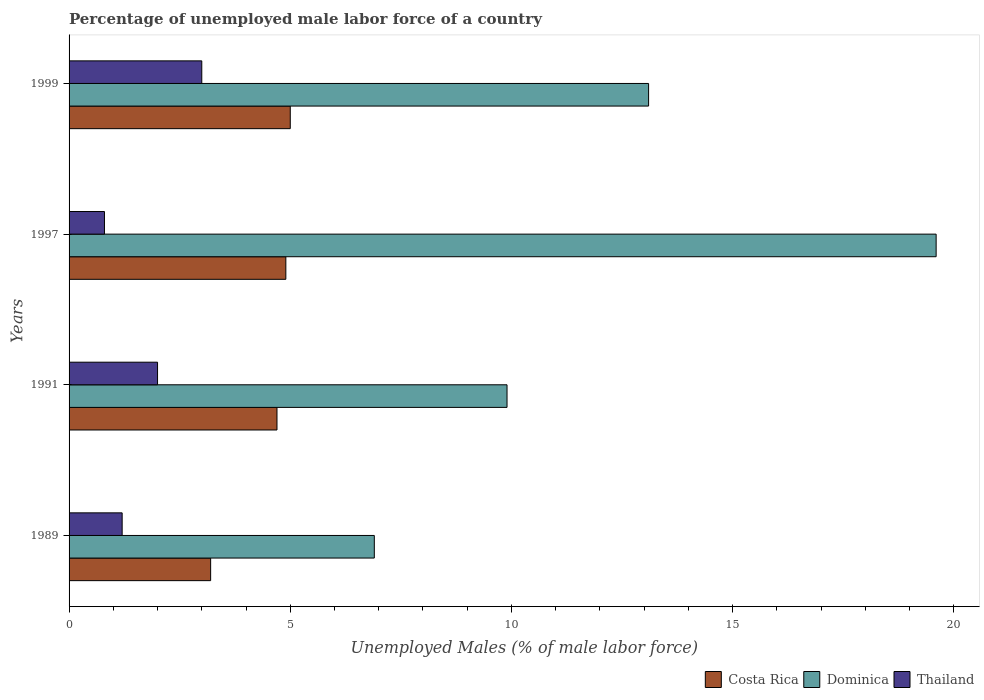How many different coloured bars are there?
Your response must be concise. 3. Are the number of bars per tick equal to the number of legend labels?
Provide a short and direct response. Yes. Are the number of bars on each tick of the Y-axis equal?
Offer a terse response. Yes. How many bars are there on the 4th tick from the top?
Offer a terse response. 3. How many bars are there on the 1st tick from the bottom?
Your response must be concise. 3. What is the label of the 4th group of bars from the top?
Make the answer very short. 1989. In how many cases, is the number of bars for a given year not equal to the number of legend labels?
Your response must be concise. 0. What is the percentage of unemployed male labor force in Costa Rica in 1999?
Offer a terse response. 5. Across all years, what is the minimum percentage of unemployed male labor force in Dominica?
Provide a succinct answer. 6.9. In which year was the percentage of unemployed male labor force in Thailand maximum?
Give a very brief answer. 1999. In which year was the percentage of unemployed male labor force in Thailand minimum?
Ensure brevity in your answer.  1997. What is the total percentage of unemployed male labor force in Dominica in the graph?
Make the answer very short. 49.5. What is the difference between the percentage of unemployed male labor force in Dominica in 1991 and that in 1999?
Provide a succinct answer. -3.2. What is the difference between the percentage of unemployed male labor force in Costa Rica in 1991 and the percentage of unemployed male labor force in Thailand in 1999?
Provide a succinct answer. 1.7. What is the average percentage of unemployed male labor force in Dominica per year?
Your answer should be compact. 12.38. In the year 1991, what is the difference between the percentage of unemployed male labor force in Dominica and percentage of unemployed male labor force in Costa Rica?
Provide a succinct answer. 5.2. What is the ratio of the percentage of unemployed male labor force in Dominica in 1997 to that in 1999?
Your answer should be very brief. 1.5. Is the percentage of unemployed male labor force in Costa Rica in 1989 less than that in 1991?
Your response must be concise. Yes. Is the difference between the percentage of unemployed male labor force in Dominica in 1991 and 1999 greater than the difference between the percentage of unemployed male labor force in Costa Rica in 1991 and 1999?
Offer a very short reply. No. What is the difference between the highest and the second highest percentage of unemployed male labor force in Dominica?
Keep it short and to the point. 6.5. What is the difference between the highest and the lowest percentage of unemployed male labor force in Costa Rica?
Offer a terse response. 1.8. Is the sum of the percentage of unemployed male labor force in Dominica in 1991 and 1999 greater than the maximum percentage of unemployed male labor force in Thailand across all years?
Make the answer very short. Yes. What does the 3rd bar from the top in 1997 represents?
Your answer should be compact. Costa Rica. What does the 2nd bar from the bottom in 1989 represents?
Your answer should be compact. Dominica. Are all the bars in the graph horizontal?
Make the answer very short. Yes. Are the values on the major ticks of X-axis written in scientific E-notation?
Keep it short and to the point. No. Does the graph contain any zero values?
Provide a short and direct response. No. Where does the legend appear in the graph?
Make the answer very short. Bottom right. How many legend labels are there?
Provide a short and direct response. 3. What is the title of the graph?
Give a very brief answer. Percentage of unemployed male labor force of a country. What is the label or title of the X-axis?
Your answer should be very brief. Unemployed Males (% of male labor force). What is the Unemployed Males (% of male labor force) in Costa Rica in 1989?
Give a very brief answer. 3.2. What is the Unemployed Males (% of male labor force) of Dominica in 1989?
Offer a very short reply. 6.9. What is the Unemployed Males (% of male labor force) of Thailand in 1989?
Provide a succinct answer. 1.2. What is the Unemployed Males (% of male labor force) in Costa Rica in 1991?
Provide a short and direct response. 4.7. What is the Unemployed Males (% of male labor force) in Dominica in 1991?
Offer a terse response. 9.9. What is the Unemployed Males (% of male labor force) of Costa Rica in 1997?
Give a very brief answer. 4.9. What is the Unemployed Males (% of male labor force) in Dominica in 1997?
Keep it short and to the point. 19.6. What is the Unemployed Males (% of male labor force) of Thailand in 1997?
Offer a terse response. 0.8. What is the Unemployed Males (% of male labor force) of Costa Rica in 1999?
Make the answer very short. 5. What is the Unemployed Males (% of male labor force) of Dominica in 1999?
Your response must be concise. 13.1. Across all years, what is the maximum Unemployed Males (% of male labor force) of Costa Rica?
Give a very brief answer. 5. Across all years, what is the maximum Unemployed Males (% of male labor force) in Dominica?
Your answer should be compact. 19.6. Across all years, what is the maximum Unemployed Males (% of male labor force) of Thailand?
Make the answer very short. 3. Across all years, what is the minimum Unemployed Males (% of male labor force) in Costa Rica?
Provide a succinct answer. 3.2. Across all years, what is the minimum Unemployed Males (% of male labor force) of Dominica?
Make the answer very short. 6.9. Across all years, what is the minimum Unemployed Males (% of male labor force) in Thailand?
Offer a terse response. 0.8. What is the total Unemployed Males (% of male labor force) in Costa Rica in the graph?
Your response must be concise. 17.8. What is the total Unemployed Males (% of male labor force) in Dominica in the graph?
Your answer should be compact. 49.5. What is the total Unemployed Males (% of male labor force) of Thailand in the graph?
Provide a short and direct response. 7. What is the difference between the Unemployed Males (% of male labor force) in Thailand in 1989 and that in 1991?
Make the answer very short. -0.8. What is the difference between the Unemployed Males (% of male labor force) in Costa Rica in 1989 and that in 1997?
Ensure brevity in your answer.  -1.7. What is the difference between the Unemployed Males (% of male labor force) of Thailand in 1989 and that in 1997?
Your answer should be very brief. 0.4. What is the difference between the Unemployed Males (% of male labor force) in Costa Rica in 1989 and that in 1999?
Offer a very short reply. -1.8. What is the difference between the Unemployed Males (% of male labor force) of Dominica in 1989 and that in 1999?
Offer a terse response. -6.2. What is the difference between the Unemployed Males (% of male labor force) of Costa Rica in 1991 and that in 1997?
Provide a succinct answer. -0.2. What is the difference between the Unemployed Males (% of male labor force) of Dominica in 1991 and that in 1997?
Your answer should be compact. -9.7. What is the difference between the Unemployed Males (% of male labor force) of Costa Rica in 1991 and that in 1999?
Offer a very short reply. -0.3. What is the difference between the Unemployed Males (% of male labor force) in Dominica in 1997 and that in 1999?
Your response must be concise. 6.5. What is the difference between the Unemployed Males (% of male labor force) of Costa Rica in 1989 and the Unemployed Males (% of male labor force) of Thailand in 1991?
Your answer should be compact. 1.2. What is the difference between the Unemployed Males (% of male labor force) in Costa Rica in 1989 and the Unemployed Males (% of male labor force) in Dominica in 1997?
Your answer should be compact. -16.4. What is the difference between the Unemployed Males (% of male labor force) in Dominica in 1989 and the Unemployed Males (% of male labor force) in Thailand in 1997?
Provide a succinct answer. 6.1. What is the difference between the Unemployed Males (% of male labor force) of Costa Rica in 1989 and the Unemployed Males (% of male labor force) of Thailand in 1999?
Keep it short and to the point. 0.2. What is the difference between the Unemployed Males (% of male labor force) in Costa Rica in 1991 and the Unemployed Males (% of male labor force) in Dominica in 1997?
Your answer should be compact. -14.9. What is the difference between the Unemployed Males (% of male labor force) of Costa Rica in 1991 and the Unemployed Males (% of male labor force) of Dominica in 1999?
Keep it short and to the point. -8.4. What is the difference between the Unemployed Males (% of male labor force) of Costa Rica in 1991 and the Unemployed Males (% of male labor force) of Thailand in 1999?
Make the answer very short. 1.7. What is the difference between the Unemployed Males (% of male labor force) of Costa Rica in 1997 and the Unemployed Males (% of male labor force) of Dominica in 1999?
Offer a terse response. -8.2. What is the average Unemployed Males (% of male labor force) in Costa Rica per year?
Your answer should be compact. 4.45. What is the average Unemployed Males (% of male labor force) in Dominica per year?
Offer a terse response. 12.38. What is the average Unemployed Males (% of male labor force) in Thailand per year?
Make the answer very short. 1.75. In the year 1989, what is the difference between the Unemployed Males (% of male labor force) in Costa Rica and Unemployed Males (% of male labor force) in Dominica?
Your answer should be very brief. -3.7. In the year 1991, what is the difference between the Unemployed Males (% of male labor force) of Costa Rica and Unemployed Males (% of male labor force) of Thailand?
Provide a short and direct response. 2.7. In the year 1991, what is the difference between the Unemployed Males (% of male labor force) of Dominica and Unemployed Males (% of male labor force) of Thailand?
Your answer should be compact. 7.9. In the year 1997, what is the difference between the Unemployed Males (% of male labor force) of Costa Rica and Unemployed Males (% of male labor force) of Dominica?
Your answer should be compact. -14.7. In the year 1997, what is the difference between the Unemployed Males (% of male labor force) in Dominica and Unemployed Males (% of male labor force) in Thailand?
Give a very brief answer. 18.8. In the year 1999, what is the difference between the Unemployed Males (% of male labor force) in Costa Rica and Unemployed Males (% of male labor force) in Thailand?
Your response must be concise. 2. In the year 1999, what is the difference between the Unemployed Males (% of male labor force) in Dominica and Unemployed Males (% of male labor force) in Thailand?
Offer a terse response. 10.1. What is the ratio of the Unemployed Males (% of male labor force) in Costa Rica in 1989 to that in 1991?
Your answer should be compact. 0.68. What is the ratio of the Unemployed Males (% of male labor force) of Dominica in 1989 to that in 1991?
Make the answer very short. 0.7. What is the ratio of the Unemployed Males (% of male labor force) in Thailand in 1989 to that in 1991?
Offer a terse response. 0.6. What is the ratio of the Unemployed Males (% of male labor force) in Costa Rica in 1989 to that in 1997?
Provide a succinct answer. 0.65. What is the ratio of the Unemployed Males (% of male labor force) in Dominica in 1989 to that in 1997?
Offer a terse response. 0.35. What is the ratio of the Unemployed Males (% of male labor force) in Thailand in 1989 to that in 1997?
Provide a succinct answer. 1.5. What is the ratio of the Unemployed Males (% of male labor force) of Costa Rica in 1989 to that in 1999?
Offer a terse response. 0.64. What is the ratio of the Unemployed Males (% of male labor force) of Dominica in 1989 to that in 1999?
Give a very brief answer. 0.53. What is the ratio of the Unemployed Males (% of male labor force) in Costa Rica in 1991 to that in 1997?
Provide a succinct answer. 0.96. What is the ratio of the Unemployed Males (% of male labor force) in Dominica in 1991 to that in 1997?
Your answer should be compact. 0.51. What is the ratio of the Unemployed Males (% of male labor force) in Thailand in 1991 to that in 1997?
Provide a succinct answer. 2.5. What is the ratio of the Unemployed Males (% of male labor force) in Costa Rica in 1991 to that in 1999?
Your answer should be very brief. 0.94. What is the ratio of the Unemployed Males (% of male labor force) in Dominica in 1991 to that in 1999?
Ensure brevity in your answer.  0.76. What is the ratio of the Unemployed Males (% of male labor force) in Thailand in 1991 to that in 1999?
Provide a succinct answer. 0.67. What is the ratio of the Unemployed Males (% of male labor force) of Costa Rica in 1997 to that in 1999?
Give a very brief answer. 0.98. What is the ratio of the Unemployed Males (% of male labor force) in Dominica in 1997 to that in 1999?
Your response must be concise. 1.5. What is the ratio of the Unemployed Males (% of male labor force) in Thailand in 1997 to that in 1999?
Provide a short and direct response. 0.27. What is the difference between the highest and the second highest Unemployed Males (% of male labor force) in Dominica?
Offer a terse response. 6.5. What is the difference between the highest and the second highest Unemployed Males (% of male labor force) of Thailand?
Provide a short and direct response. 1. 